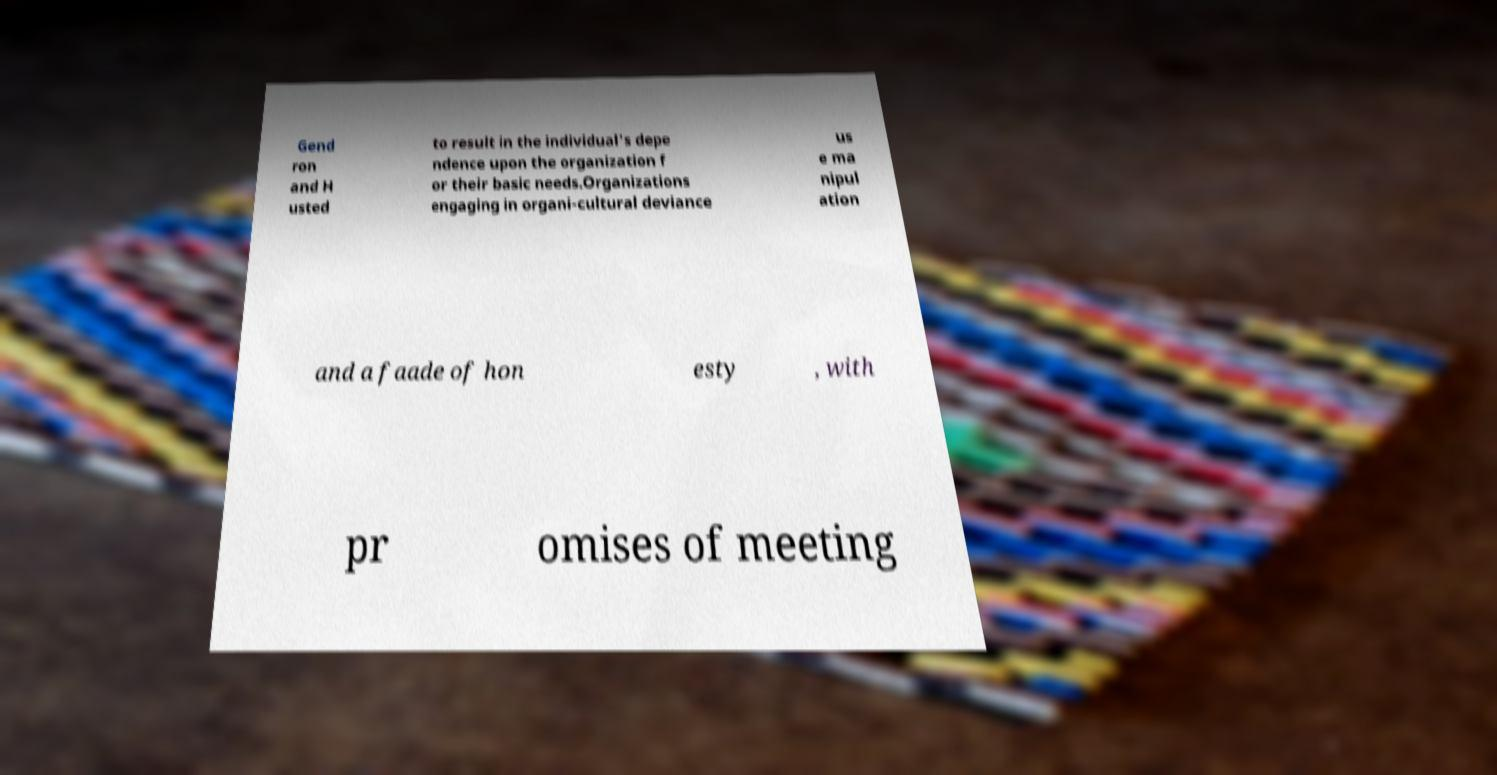Can you read and provide the text displayed in the image?This photo seems to have some interesting text. Can you extract and type it out for me? Gend ron and H usted to result in the individual's depe ndence upon the organization f or their basic needs.Organizations engaging in organi-cultural deviance us e ma nipul ation and a faade of hon esty , with pr omises of meeting 